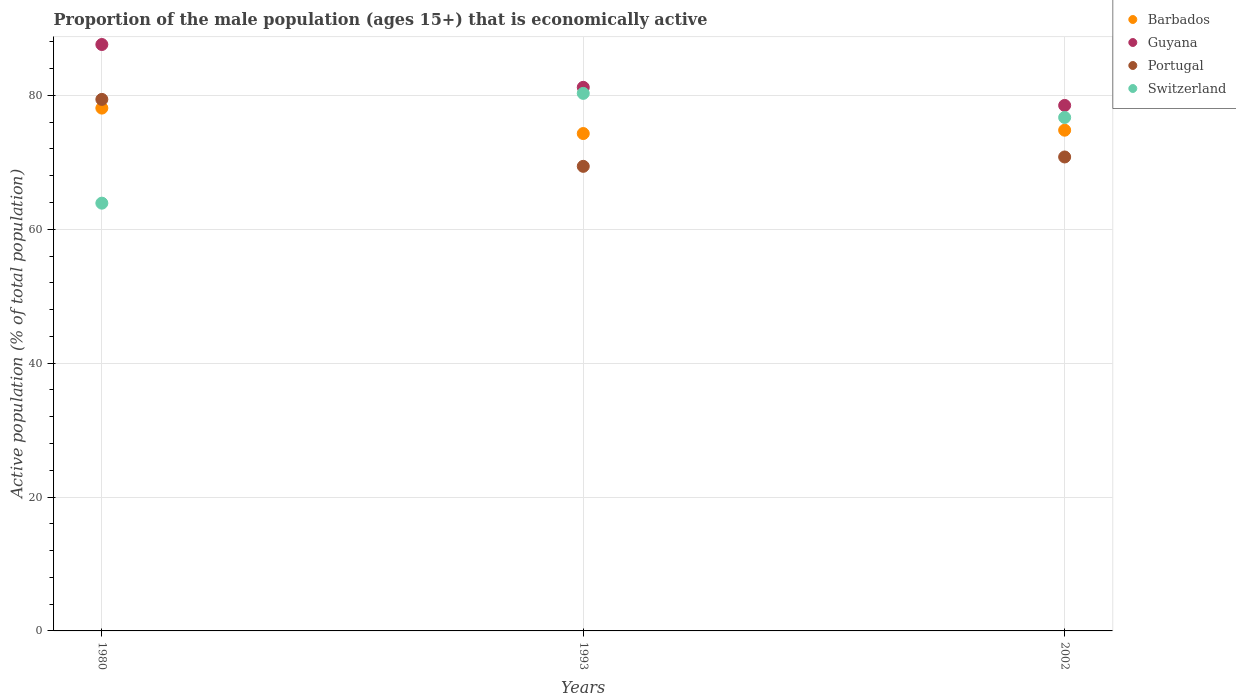What is the proportion of the male population that is economically active in Guyana in 1993?
Your response must be concise. 81.2. Across all years, what is the maximum proportion of the male population that is economically active in Portugal?
Offer a very short reply. 79.4. Across all years, what is the minimum proportion of the male population that is economically active in Guyana?
Your answer should be very brief. 78.5. In which year was the proportion of the male population that is economically active in Guyana minimum?
Offer a very short reply. 2002. What is the total proportion of the male population that is economically active in Switzerland in the graph?
Your answer should be very brief. 220.9. What is the difference between the proportion of the male population that is economically active in Portugal in 1993 and that in 2002?
Ensure brevity in your answer.  -1.4. What is the difference between the proportion of the male population that is economically active in Portugal in 2002 and the proportion of the male population that is economically active in Barbados in 1980?
Keep it short and to the point. -7.3. What is the average proportion of the male population that is economically active in Barbados per year?
Give a very brief answer. 75.73. In the year 1980, what is the difference between the proportion of the male population that is economically active in Switzerland and proportion of the male population that is economically active in Portugal?
Your response must be concise. -15.5. In how many years, is the proportion of the male population that is economically active in Barbados greater than 64 %?
Your response must be concise. 3. What is the ratio of the proportion of the male population that is economically active in Guyana in 1980 to that in 1993?
Provide a short and direct response. 1.08. What is the difference between the highest and the second highest proportion of the male population that is economically active in Portugal?
Your answer should be very brief. 8.6. What is the difference between the highest and the lowest proportion of the male population that is economically active in Switzerland?
Offer a terse response. 16.4. In how many years, is the proportion of the male population that is economically active in Switzerland greater than the average proportion of the male population that is economically active in Switzerland taken over all years?
Your answer should be compact. 2. Is the sum of the proportion of the male population that is economically active in Barbados in 1980 and 2002 greater than the maximum proportion of the male population that is economically active in Guyana across all years?
Ensure brevity in your answer.  Yes. Does the proportion of the male population that is economically active in Guyana monotonically increase over the years?
Provide a succinct answer. No. Is the proportion of the male population that is economically active in Guyana strictly greater than the proportion of the male population that is economically active in Barbados over the years?
Keep it short and to the point. Yes. How many dotlines are there?
Your response must be concise. 4. How many years are there in the graph?
Provide a succinct answer. 3. What is the difference between two consecutive major ticks on the Y-axis?
Offer a very short reply. 20. Are the values on the major ticks of Y-axis written in scientific E-notation?
Provide a short and direct response. No. Does the graph contain any zero values?
Offer a very short reply. No. Where does the legend appear in the graph?
Keep it short and to the point. Top right. What is the title of the graph?
Provide a succinct answer. Proportion of the male population (ages 15+) that is economically active. Does "Korea (Republic)" appear as one of the legend labels in the graph?
Your response must be concise. No. What is the label or title of the Y-axis?
Offer a very short reply. Active population (% of total population). What is the Active population (% of total population) in Barbados in 1980?
Keep it short and to the point. 78.1. What is the Active population (% of total population) of Guyana in 1980?
Offer a terse response. 87.6. What is the Active population (% of total population) in Portugal in 1980?
Offer a terse response. 79.4. What is the Active population (% of total population) in Switzerland in 1980?
Your response must be concise. 63.9. What is the Active population (% of total population) in Barbados in 1993?
Provide a short and direct response. 74.3. What is the Active population (% of total population) in Guyana in 1993?
Keep it short and to the point. 81.2. What is the Active population (% of total population) in Portugal in 1993?
Your response must be concise. 69.4. What is the Active population (% of total population) in Switzerland in 1993?
Your answer should be compact. 80.3. What is the Active population (% of total population) in Barbados in 2002?
Offer a terse response. 74.8. What is the Active population (% of total population) in Guyana in 2002?
Offer a terse response. 78.5. What is the Active population (% of total population) of Portugal in 2002?
Give a very brief answer. 70.8. What is the Active population (% of total population) of Switzerland in 2002?
Your answer should be compact. 76.7. Across all years, what is the maximum Active population (% of total population) of Barbados?
Your answer should be compact. 78.1. Across all years, what is the maximum Active population (% of total population) of Guyana?
Give a very brief answer. 87.6. Across all years, what is the maximum Active population (% of total population) in Portugal?
Give a very brief answer. 79.4. Across all years, what is the maximum Active population (% of total population) of Switzerland?
Your answer should be very brief. 80.3. Across all years, what is the minimum Active population (% of total population) in Barbados?
Your response must be concise. 74.3. Across all years, what is the minimum Active population (% of total population) of Guyana?
Your response must be concise. 78.5. Across all years, what is the minimum Active population (% of total population) in Portugal?
Your answer should be very brief. 69.4. Across all years, what is the minimum Active population (% of total population) of Switzerland?
Provide a short and direct response. 63.9. What is the total Active population (% of total population) of Barbados in the graph?
Your answer should be very brief. 227.2. What is the total Active population (% of total population) in Guyana in the graph?
Offer a terse response. 247.3. What is the total Active population (% of total population) in Portugal in the graph?
Your response must be concise. 219.6. What is the total Active population (% of total population) of Switzerland in the graph?
Ensure brevity in your answer.  220.9. What is the difference between the Active population (% of total population) of Portugal in 1980 and that in 1993?
Your answer should be very brief. 10. What is the difference between the Active population (% of total population) in Switzerland in 1980 and that in 1993?
Your answer should be very brief. -16.4. What is the difference between the Active population (% of total population) in Barbados in 1980 and that in 2002?
Keep it short and to the point. 3.3. What is the difference between the Active population (% of total population) in Switzerland in 1993 and that in 2002?
Offer a terse response. 3.6. What is the difference between the Active population (% of total population) in Barbados in 1980 and the Active population (% of total population) in Guyana in 1993?
Keep it short and to the point. -3.1. What is the difference between the Active population (% of total population) of Guyana in 1980 and the Active population (% of total population) of Switzerland in 1993?
Ensure brevity in your answer.  7.3. What is the difference between the Active population (% of total population) of Portugal in 1980 and the Active population (% of total population) of Switzerland in 1993?
Offer a terse response. -0.9. What is the difference between the Active population (% of total population) in Barbados in 1980 and the Active population (% of total population) in Switzerland in 2002?
Provide a short and direct response. 1.4. What is the difference between the Active population (% of total population) of Guyana in 1980 and the Active population (% of total population) of Portugal in 2002?
Make the answer very short. 16.8. What is the difference between the Active population (% of total population) in Barbados in 1993 and the Active population (% of total population) in Portugal in 2002?
Ensure brevity in your answer.  3.5. What is the difference between the Active population (% of total population) in Barbados in 1993 and the Active population (% of total population) in Switzerland in 2002?
Provide a short and direct response. -2.4. What is the difference between the Active population (% of total population) in Guyana in 1993 and the Active population (% of total population) in Switzerland in 2002?
Provide a succinct answer. 4.5. What is the average Active population (% of total population) of Barbados per year?
Offer a terse response. 75.73. What is the average Active population (% of total population) of Guyana per year?
Make the answer very short. 82.43. What is the average Active population (% of total population) in Portugal per year?
Make the answer very short. 73.2. What is the average Active population (% of total population) in Switzerland per year?
Offer a very short reply. 73.63. In the year 1980, what is the difference between the Active population (% of total population) of Barbados and Active population (% of total population) of Guyana?
Provide a short and direct response. -9.5. In the year 1980, what is the difference between the Active population (% of total population) of Barbados and Active population (% of total population) of Switzerland?
Provide a short and direct response. 14.2. In the year 1980, what is the difference between the Active population (% of total population) in Guyana and Active population (% of total population) in Switzerland?
Your answer should be compact. 23.7. In the year 1993, what is the difference between the Active population (% of total population) of Guyana and Active population (% of total population) of Portugal?
Offer a terse response. 11.8. In the year 1993, what is the difference between the Active population (% of total population) of Guyana and Active population (% of total population) of Switzerland?
Your response must be concise. 0.9. In the year 2002, what is the difference between the Active population (% of total population) in Barbados and Active population (% of total population) in Guyana?
Provide a short and direct response. -3.7. In the year 2002, what is the difference between the Active population (% of total population) in Barbados and Active population (% of total population) in Switzerland?
Your answer should be compact. -1.9. What is the ratio of the Active population (% of total population) of Barbados in 1980 to that in 1993?
Your answer should be compact. 1.05. What is the ratio of the Active population (% of total population) in Guyana in 1980 to that in 1993?
Provide a short and direct response. 1.08. What is the ratio of the Active population (% of total population) of Portugal in 1980 to that in 1993?
Give a very brief answer. 1.14. What is the ratio of the Active population (% of total population) of Switzerland in 1980 to that in 1993?
Keep it short and to the point. 0.8. What is the ratio of the Active population (% of total population) of Barbados in 1980 to that in 2002?
Provide a short and direct response. 1.04. What is the ratio of the Active population (% of total population) of Guyana in 1980 to that in 2002?
Offer a very short reply. 1.12. What is the ratio of the Active population (% of total population) in Portugal in 1980 to that in 2002?
Give a very brief answer. 1.12. What is the ratio of the Active population (% of total population) of Switzerland in 1980 to that in 2002?
Provide a succinct answer. 0.83. What is the ratio of the Active population (% of total population) of Barbados in 1993 to that in 2002?
Your response must be concise. 0.99. What is the ratio of the Active population (% of total population) of Guyana in 1993 to that in 2002?
Offer a terse response. 1.03. What is the ratio of the Active population (% of total population) in Portugal in 1993 to that in 2002?
Make the answer very short. 0.98. What is the ratio of the Active population (% of total population) of Switzerland in 1993 to that in 2002?
Ensure brevity in your answer.  1.05. What is the difference between the highest and the second highest Active population (% of total population) in Barbados?
Your answer should be very brief. 3.3. What is the difference between the highest and the second highest Active population (% of total population) in Portugal?
Provide a short and direct response. 8.6. What is the difference between the highest and the lowest Active population (% of total population) of Portugal?
Offer a terse response. 10. 